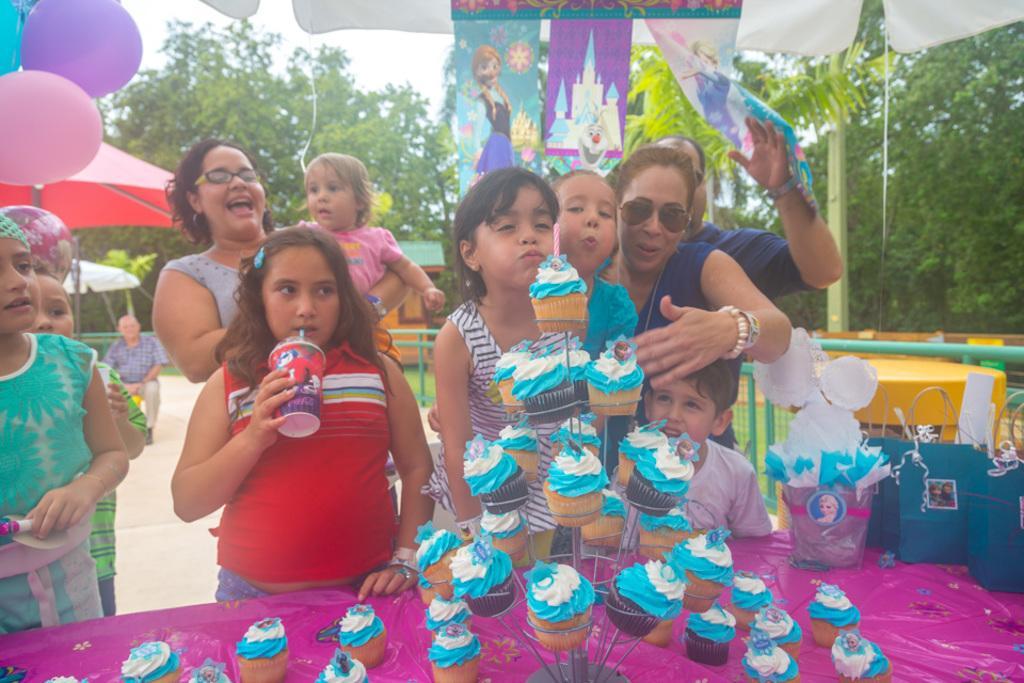In one or two sentences, can you explain what this image depicts? In this image I can see few people are standing. Here I can see few carry bags and number of cupcakes. In the background I can see few balloons, number of trees and few shades. 